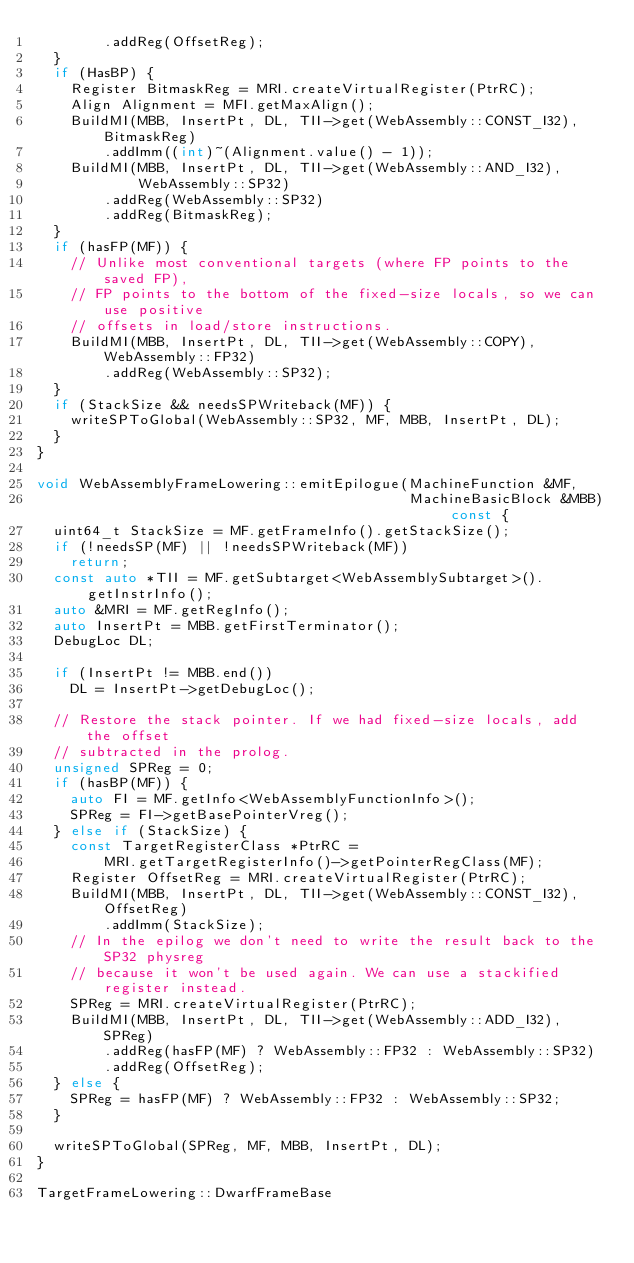<code> <loc_0><loc_0><loc_500><loc_500><_C++_>        .addReg(OffsetReg);
  }
  if (HasBP) {
    Register BitmaskReg = MRI.createVirtualRegister(PtrRC);
    Align Alignment = MFI.getMaxAlign();
    BuildMI(MBB, InsertPt, DL, TII->get(WebAssembly::CONST_I32), BitmaskReg)
        .addImm((int)~(Alignment.value() - 1));
    BuildMI(MBB, InsertPt, DL, TII->get(WebAssembly::AND_I32),
            WebAssembly::SP32)
        .addReg(WebAssembly::SP32)
        .addReg(BitmaskReg);
  }
  if (hasFP(MF)) {
    // Unlike most conventional targets (where FP points to the saved FP),
    // FP points to the bottom of the fixed-size locals, so we can use positive
    // offsets in load/store instructions.
    BuildMI(MBB, InsertPt, DL, TII->get(WebAssembly::COPY), WebAssembly::FP32)
        .addReg(WebAssembly::SP32);
  }
  if (StackSize && needsSPWriteback(MF)) {
    writeSPToGlobal(WebAssembly::SP32, MF, MBB, InsertPt, DL);
  }
}

void WebAssemblyFrameLowering::emitEpilogue(MachineFunction &MF,
                                            MachineBasicBlock &MBB) const {
  uint64_t StackSize = MF.getFrameInfo().getStackSize();
  if (!needsSP(MF) || !needsSPWriteback(MF))
    return;
  const auto *TII = MF.getSubtarget<WebAssemblySubtarget>().getInstrInfo();
  auto &MRI = MF.getRegInfo();
  auto InsertPt = MBB.getFirstTerminator();
  DebugLoc DL;

  if (InsertPt != MBB.end())
    DL = InsertPt->getDebugLoc();

  // Restore the stack pointer. If we had fixed-size locals, add the offset
  // subtracted in the prolog.
  unsigned SPReg = 0;
  if (hasBP(MF)) {
    auto FI = MF.getInfo<WebAssemblyFunctionInfo>();
    SPReg = FI->getBasePointerVreg();
  } else if (StackSize) {
    const TargetRegisterClass *PtrRC =
        MRI.getTargetRegisterInfo()->getPointerRegClass(MF);
    Register OffsetReg = MRI.createVirtualRegister(PtrRC);
    BuildMI(MBB, InsertPt, DL, TII->get(WebAssembly::CONST_I32), OffsetReg)
        .addImm(StackSize);
    // In the epilog we don't need to write the result back to the SP32 physreg
    // because it won't be used again. We can use a stackified register instead.
    SPReg = MRI.createVirtualRegister(PtrRC);
    BuildMI(MBB, InsertPt, DL, TII->get(WebAssembly::ADD_I32), SPReg)
        .addReg(hasFP(MF) ? WebAssembly::FP32 : WebAssembly::SP32)
        .addReg(OffsetReg);
  } else {
    SPReg = hasFP(MF) ? WebAssembly::FP32 : WebAssembly::SP32;
  }

  writeSPToGlobal(SPReg, MF, MBB, InsertPt, DL);
}

TargetFrameLowering::DwarfFrameBase</code> 